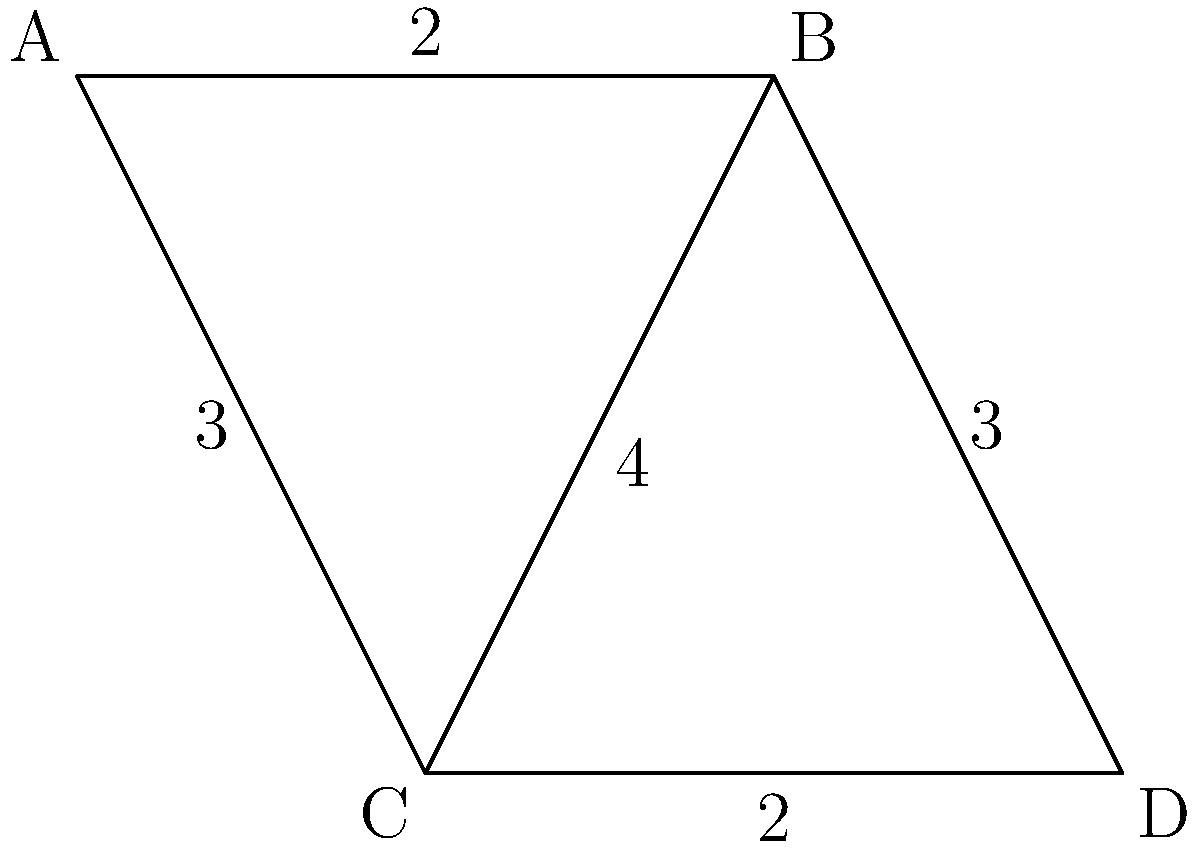Consider a smart traffic routing network represented by the graph above, where nodes represent intersections and edge weights represent fuel efficiency scores (higher is better). What is the order of the automorphism group of this graph, and how does this information relate to potential fuel savings in the network? To solve this problem, we'll follow these steps:

1) First, let's identify the automorphisms of the graph:
   - The identity automorphism (leaves all vertices in place)
   - Swapping A and D
   - Swapping B and C
   - Swapping both (A,D) and (B,C)

2) The number of these automorphisms gives us the order of the automorphism group, which is 4.

3) Now, let's interpret this in terms of fuel efficiency:
   - Each automorphism represents a way to rearrange the network while preserving its structure and edge weights.
   - The order of the automorphism group (4) tells us how many such rearrangements exist.

4) In terms of fuel efficiency:
   - A higher order suggests more symmetry and potentially more balanced fuel efficiency across the network.
   - With 4 automorphisms, we have a moderately symmetric network, indicating some balance in fuel efficiency.

5) Potential for fuel savings:
   - The symmetry suggests that rerouting traffic through equivalent paths (under these automorphisms) could distribute the load more evenly.
   - This could lead to reduced congestion and improved overall fuel efficiency.

6) However, the limited number of automorphisms (only 4) also suggests that there might be some unique, critical paths in the network that can't be easily substituted, which could be targets for focused improvement efforts.
Answer: 4; moderate symmetry allows some load balancing for fuel efficiency, but limited automorphisms indicate critical paths for targeted improvements. 